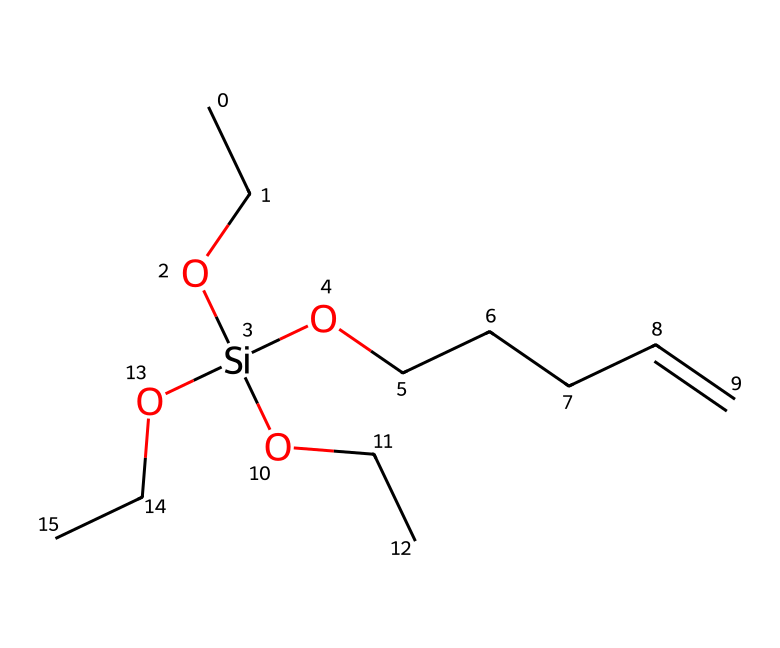What is the main functional group present in this silane? The silane structure contains hydroxyl (-OH) groups along with silicon, indicating the presence of silanol functional groups.
Answer: silanol How many carbon atoms are present in this compound? By analyzing the structure, there are six carbon atoms indicated in the SMILES representation, including those in the chains and the main structure.
Answer: six What type of reaction can this silane undergo due to its functional groups? The hydroxyl groups allow this silane to undergo hydrolysis, which can enhance adhesion by silanization on various surfaces.
Answer: hydrolysis How many silicon atoms are in this chemical structure? A careful observation of the SMILES shows that there is one silicon atom connected to three different functional groups.
Answer: one What is the anionic nature of the alkyl groups in this silane? The alkyl groups attached to the silicon do not display ionic characteristics; they are non-polar and hydrophobic in nature, affecting adhesion properties.
Answer: non-polar In what applications are silane coupling agents like this typically used? Silane coupling agents are primarily used to improve adhesion in composite materials and coatings, enhancing surface interactions.
Answer: coatings 